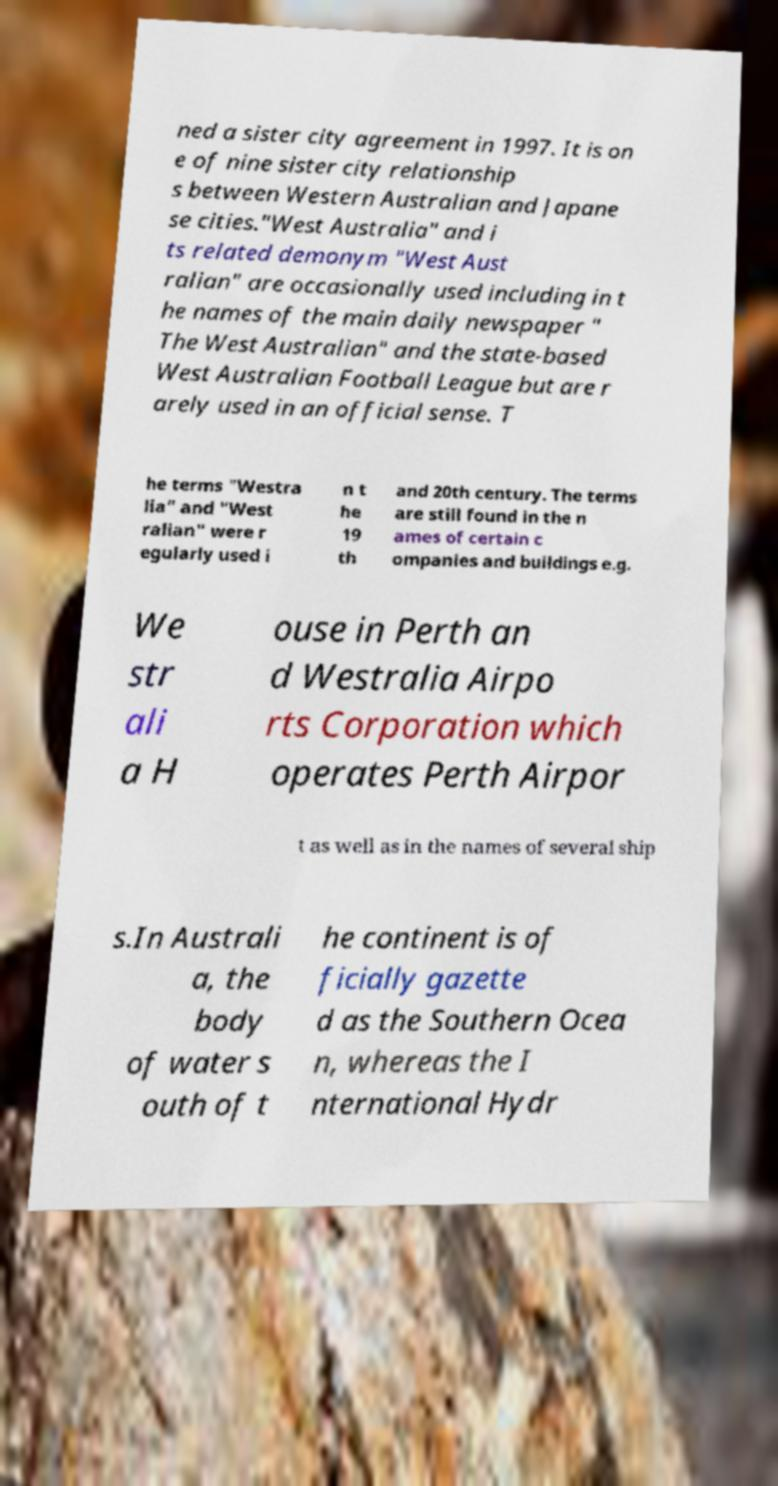Could you assist in decoding the text presented in this image and type it out clearly? ned a sister city agreement in 1997. It is on e of nine sister city relationship s between Western Australian and Japane se cities."West Australia" and i ts related demonym "West Aust ralian" are occasionally used including in t he names of the main daily newspaper " The West Australian" and the state-based West Australian Football League but are r arely used in an official sense. T he terms "Westra lia" and "West ralian" were r egularly used i n t he 19 th and 20th century. The terms are still found in the n ames of certain c ompanies and buildings e.g. We str ali a H ouse in Perth an d Westralia Airpo rts Corporation which operates Perth Airpor t as well as in the names of several ship s.In Australi a, the body of water s outh of t he continent is of ficially gazette d as the Southern Ocea n, whereas the I nternational Hydr 